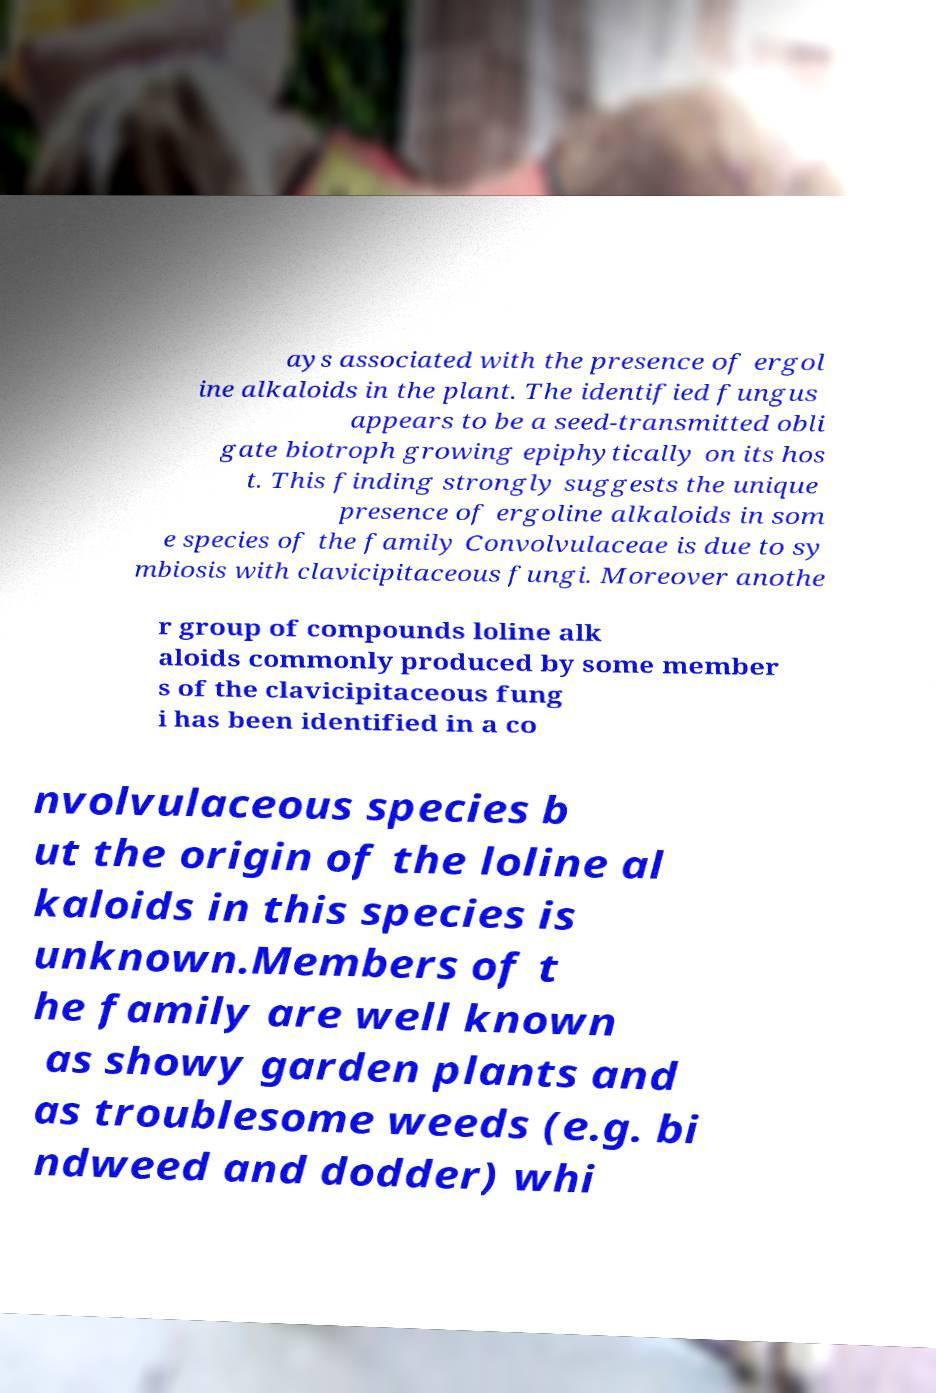I need the written content from this picture converted into text. Can you do that? ays associated with the presence of ergol ine alkaloids in the plant. The identified fungus appears to be a seed-transmitted obli gate biotroph growing epiphytically on its hos t. This finding strongly suggests the unique presence of ergoline alkaloids in som e species of the family Convolvulaceae is due to sy mbiosis with clavicipitaceous fungi. Moreover anothe r group of compounds loline alk aloids commonly produced by some member s of the clavicipitaceous fung i has been identified in a co nvolvulaceous species b ut the origin of the loline al kaloids in this species is unknown.Members of t he family are well known as showy garden plants and as troublesome weeds (e.g. bi ndweed and dodder) whi 